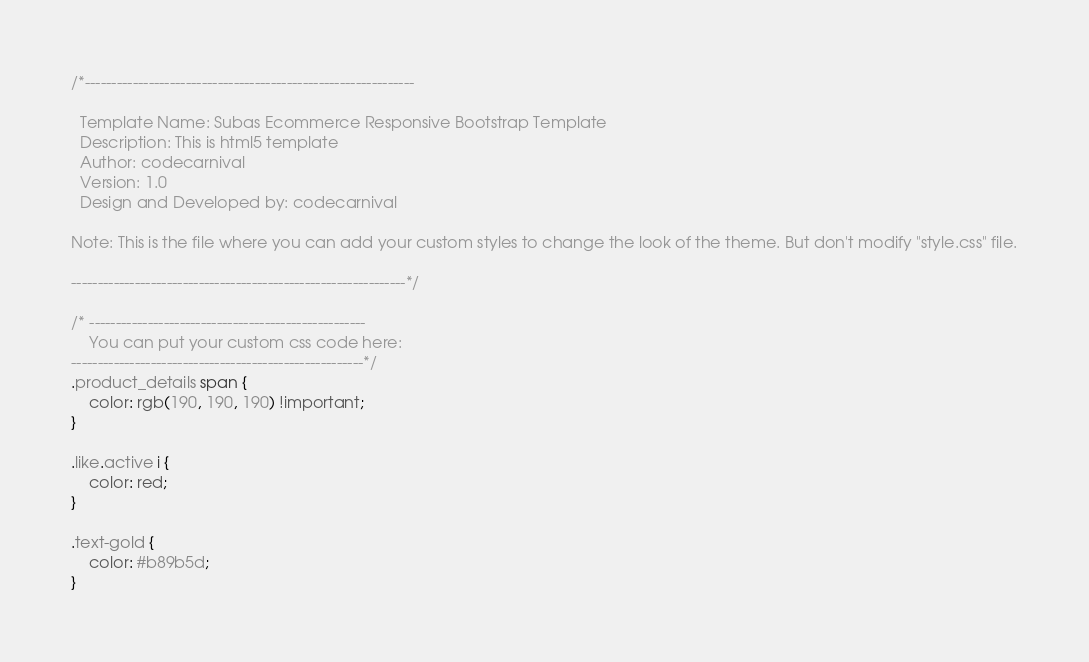Convert code to text. <code><loc_0><loc_0><loc_500><loc_500><_CSS_>/*--------------------------------------------------------------

  Template Name: Subas Ecommerce Responsive Bootstrap Template
  Description: This is html5 template
  Author: codecarnival
  Version: 1.0
  Design and Developed by: codecarnival

Note: This is the file where you can add your custom styles to change the look of the theme. But don't modify "style.css" file.

---------------------------------------------------------------*/

/* ----------------------------------------------------
	You can put your custom css code here: 
-------------------------------------------------------*/
.product_details span {
    color: rgb(190, 190, 190) !important;
}

.like.active i {
    color: red;
}

.text-gold {
    color: #b89b5d;
}
</code> 